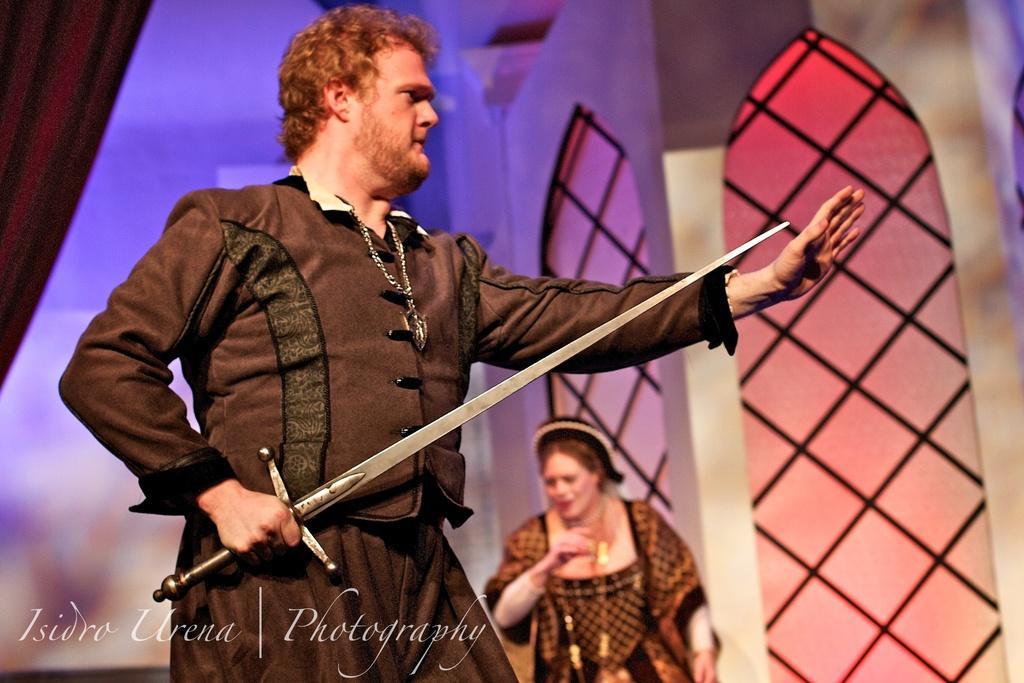Describe this image in one or two sentences. In the image we can see a man wearing clothes and neck chain, and the man is holding a sword in his hand. This is a watermark and behind him there is a woman standing, wearing clothes, this is a building and the background is blurred. 